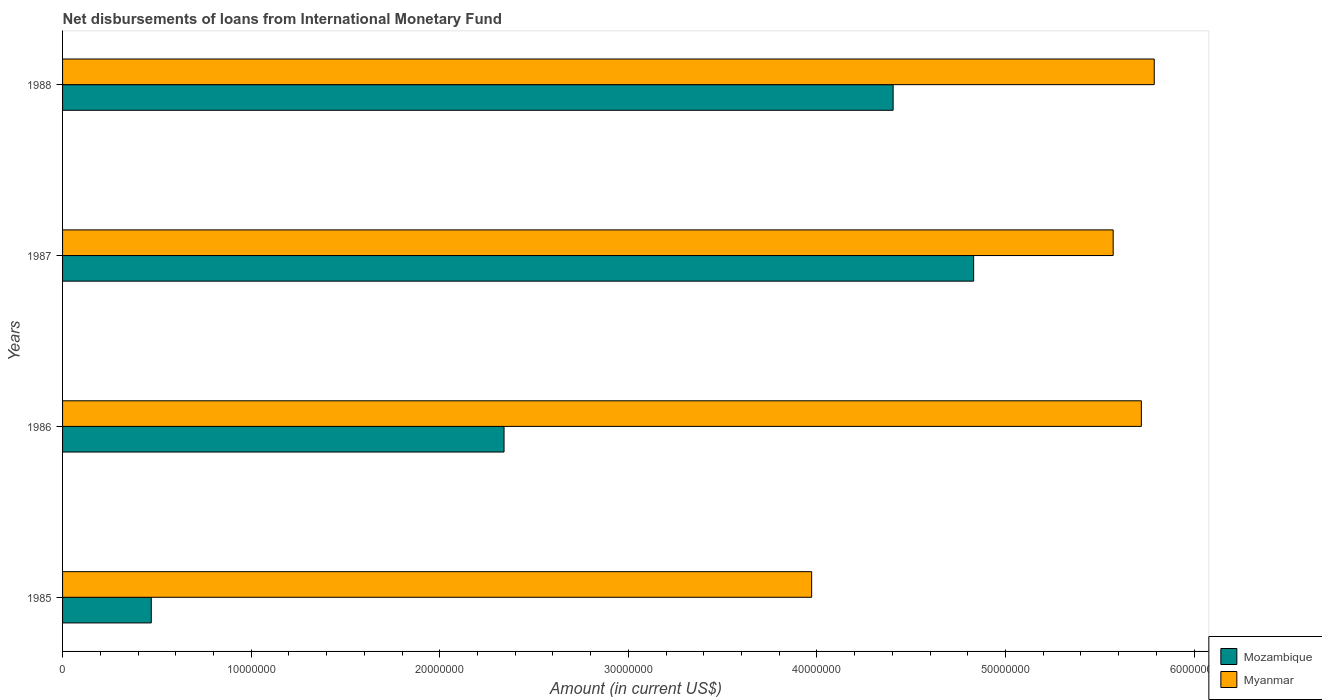How many different coloured bars are there?
Offer a very short reply. 2. What is the amount of loans disbursed in Myanmar in 1987?
Your answer should be very brief. 5.57e+07. Across all years, what is the maximum amount of loans disbursed in Mozambique?
Keep it short and to the point. 4.83e+07. Across all years, what is the minimum amount of loans disbursed in Myanmar?
Ensure brevity in your answer.  3.97e+07. In which year was the amount of loans disbursed in Myanmar maximum?
Make the answer very short. 1988. What is the total amount of loans disbursed in Mozambique in the graph?
Your response must be concise. 1.20e+08. What is the difference between the amount of loans disbursed in Mozambique in 1987 and that in 1988?
Provide a short and direct response. 4.27e+06. What is the difference between the amount of loans disbursed in Myanmar in 1987 and the amount of loans disbursed in Mozambique in 1986?
Keep it short and to the point. 3.23e+07. What is the average amount of loans disbursed in Mozambique per year?
Ensure brevity in your answer.  3.01e+07. In the year 1988, what is the difference between the amount of loans disbursed in Myanmar and amount of loans disbursed in Mozambique?
Your answer should be compact. 1.38e+07. What is the ratio of the amount of loans disbursed in Myanmar in 1986 to that in 1987?
Ensure brevity in your answer.  1.03. What is the difference between the highest and the second highest amount of loans disbursed in Mozambique?
Your response must be concise. 4.27e+06. What is the difference between the highest and the lowest amount of loans disbursed in Myanmar?
Offer a very short reply. 1.82e+07. In how many years, is the amount of loans disbursed in Mozambique greater than the average amount of loans disbursed in Mozambique taken over all years?
Your answer should be very brief. 2. Is the sum of the amount of loans disbursed in Mozambique in 1986 and 1988 greater than the maximum amount of loans disbursed in Myanmar across all years?
Your response must be concise. Yes. What does the 1st bar from the top in 1986 represents?
Provide a succinct answer. Myanmar. What does the 2nd bar from the bottom in 1987 represents?
Your response must be concise. Myanmar. Are all the bars in the graph horizontal?
Ensure brevity in your answer.  Yes. Are the values on the major ticks of X-axis written in scientific E-notation?
Your answer should be compact. No. Does the graph contain any zero values?
Make the answer very short. No. Where does the legend appear in the graph?
Make the answer very short. Bottom right. How many legend labels are there?
Provide a succinct answer. 2. How are the legend labels stacked?
Provide a succinct answer. Vertical. What is the title of the graph?
Ensure brevity in your answer.  Net disbursements of loans from International Monetary Fund. Does "Australia" appear as one of the legend labels in the graph?
Provide a short and direct response. No. What is the label or title of the X-axis?
Offer a terse response. Amount (in current US$). What is the Amount (in current US$) in Mozambique in 1985?
Offer a very short reply. 4.70e+06. What is the Amount (in current US$) of Myanmar in 1985?
Provide a succinct answer. 3.97e+07. What is the Amount (in current US$) of Mozambique in 1986?
Keep it short and to the point. 2.34e+07. What is the Amount (in current US$) in Myanmar in 1986?
Keep it short and to the point. 5.72e+07. What is the Amount (in current US$) of Mozambique in 1987?
Keep it short and to the point. 4.83e+07. What is the Amount (in current US$) of Myanmar in 1987?
Make the answer very short. 5.57e+07. What is the Amount (in current US$) of Mozambique in 1988?
Offer a terse response. 4.40e+07. What is the Amount (in current US$) in Myanmar in 1988?
Make the answer very short. 5.79e+07. Across all years, what is the maximum Amount (in current US$) in Mozambique?
Give a very brief answer. 4.83e+07. Across all years, what is the maximum Amount (in current US$) of Myanmar?
Give a very brief answer. 5.79e+07. Across all years, what is the minimum Amount (in current US$) in Mozambique?
Your answer should be compact. 4.70e+06. Across all years, what is the minimum Amount (in current US$) of Myanmar?
Provide a short and direct response. 3.97e+07. What is the total Amount (in current US$) of Mozambique in the graph?
Provide a short and direct response. 1.20e+08. What is the total Amount (in current US$) in Myanmar in the graph?
Offer a very short reply. 2.11e+08. What is the difference between the Amount (in current US$) in Mozambique in 1985 and that in 1986?
Make the answer very short. -1.87e+07. What is the difference between the Amount (in current US$) in Myanmar in 1985 and that in 1986?
Your answer should be compact. -1.75e+07. What is the difference between the Amount (in current US$) in Mozambique in 1985 and that in 1987?
Provide a short and direct response. -4.36e+07. What is the difference between the Amount (in current US$) of Myanmar in 1985 and that in 1987?
Offer a terse response. -1.60e+07. What is the difference between the Amount (in current US$) in Mozambique in 1985 and that in 1988?
Offer a very short reply. -3.93e+07. What is the difference between the Amount (in current US$) in Myanmar in 1985 and that in 1988?
Offer a very short reply. -1.82e+07. What is the difference between the Amount (in current US$) of Mozambique in 1986 and that in 1987?
Your answer should be compact. -2.49e+07. What is the difference between the Amount (in current US$) in Myanmar in 1986 and that in 1987?
Keep it short and to the point. 1.49e+06. What is the difference between the Amount (in current US$) in Mozambique in 1986 and that in 1988?
Your answer should be compact. -2.06e+07. What is the difference between the Amount (in current US$) in Myanmar in 1986 and that in 1988?
Provide a short and direct response. -6.84e+05. What is the difference between the Amount (in current US$) in Mozambique in 1987 and that in 1988?
Your response must be concise. 4.27e+06. What is the difference between the Amount (in current US$) of Myanmar in 1987 and that in 1988?
Ensure brevity in your answer.  -2.18e+06. What is the difference between the Amount (in current US$) of Mozambique in 1985 and the Amount (in current US$) of Myanmar in 1986?
Provide a succinct answer. -5.25e+07. What is the difference between the Amount (in current US$) in Mozambique in 1985 and the Amount (in current US$) in Myanmar in 1987?
Give a very brief answer. -5.10e+07. What is the difference between the Amount (in current US$) in Mozambique in 1985 and the Amount (in current US$) in Myanmar in 1988?
Keep it short and to the point. -5.32e+07. What is the difference between the Amount (in current US$) of Mozambique in 1986 and the Amount (in current US$) of Myanmar in 1987?
Your response must be concise. -3.23e+07. What is the difference between the Amount (in current US$) in Mozambique in 1986 and the Amount (in current US$) in Myanmar in 1988?
Ensure brevity in your answer.  -3.45e+07. What is the difference between the Amount (in current US$) of Mozambique in 1987 and the Amount (in current US$) of Myanmar in 1988?
Offer a very short reply. -9.58e+06. What is the average Amount (in current US$) in Mozambique per year?
Your answer should be very brief. 3.01e+07. What is the average Amount (in current US$) in Myanmar per year?
Ensure brevity in your answer.  5.26e+07. In the year 1985, what is the difference between the Amount (in current US$) of Mozambique and Amount (in current US$) of Myanmar?
Provide a short and direct response. -3.50e+07. In the year 1986, what is the difference between the Amount (in current US$) in Mozambique and Amount (in current US$) in Myanmar?
Ensure brevity in your answer.  -3.38e+07. In the year 1987, what is the difference between the Amount (in current US$) of Mozambique and Amount (in current US$) of Myanmar?
Give a very brief answer. -7.40e+06. In the year 1988, what is the difference between the Amount (in current US$) in Mozambique and Amount (in current US$) in Myanmar?
Provide a short and direct response. -1.38e+07. What is the ratio of the Amount (in current US$) in Mozambique in 1985 to that in 1986?
Provide a succinct answer. 0.2. What is the ratio of the Amount (in current US$) of Myanmar in 1985 to that in 1986?
Make the answer very short. 0.69. What is the ratio of the Amount (in current US$) in Mozambique in 1985 to that in 1987?
Provide a succinct answer. 0.1. What is the ratio of the Amount (in current US$) in Myanmar in 1985 to that in 1987?
Provide a succinct answer. 0.71. What is the ratio of the Amount (in current US$) of Mozambique in 1985 to that in 1988?
Your answer should be compact. 0.11. What is the ratio of the Amount (in current US$) of Myanmar in 1985 to that in 1988?
Give a very brief answer. 0.69. What is the ratio of the Amount (in current US$) in Mozambique in 1986 to that in 1987?
Your response must be concise. 0.48. What is the ratio of the Amount (in current US$) of Myanmar in 1986 to that in 1987?
Ensure brevity in your answer.  1.03. What is the ratio of the Amount (in current US$) of Mozambique in 1986 to that in 1988?
Give a very brief answer. 0.53. What is the ratio of the Amount (in current US$) in Mozambique in 1987 to that in 1988?
Provide a short and direct response. 1.1. What is the ratio of the Amount (in current US$) in Myanmar in 1987 to that in 1988?
Ensure brevity in your answer.  0.96. What is the difference between the highest and the second highest Amount (in current US$) in Mozambique?
Ensure brevity in your answer.  4.27e+06. What is the difference between the highest and the second highest Amount (in current US$) of Myanmar?
Make the answer very short. 6.84e+05. What is the difference between the highest and the lowest Amount (in current US$) in Mozambique?
Keep it short and to the point. 4.36e+07. What is the difference between the highest and the lowest Amount (in current US$) of Myanmar?
Ensure brevity in your answer.  1.82e+07. 